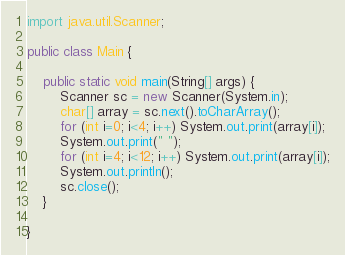Convert code to text. <code><loc_0><loc_0><loc_500><loc_500><_Java_>import java.util.Scanner;

public class Main {

	public static void main(String[] args) {
		Scanner sc = new Scanner(System.in);
		char[] array = sc.next().toCharArray();
		for (int i=0; i<4; i++) System.out.print(array[i]);
		System.out.print(" ");
		for (int i=4; i<12; i++) System.out.print(array[i]);
		System.out.println();
		sc.close();
	}

}
</code> 